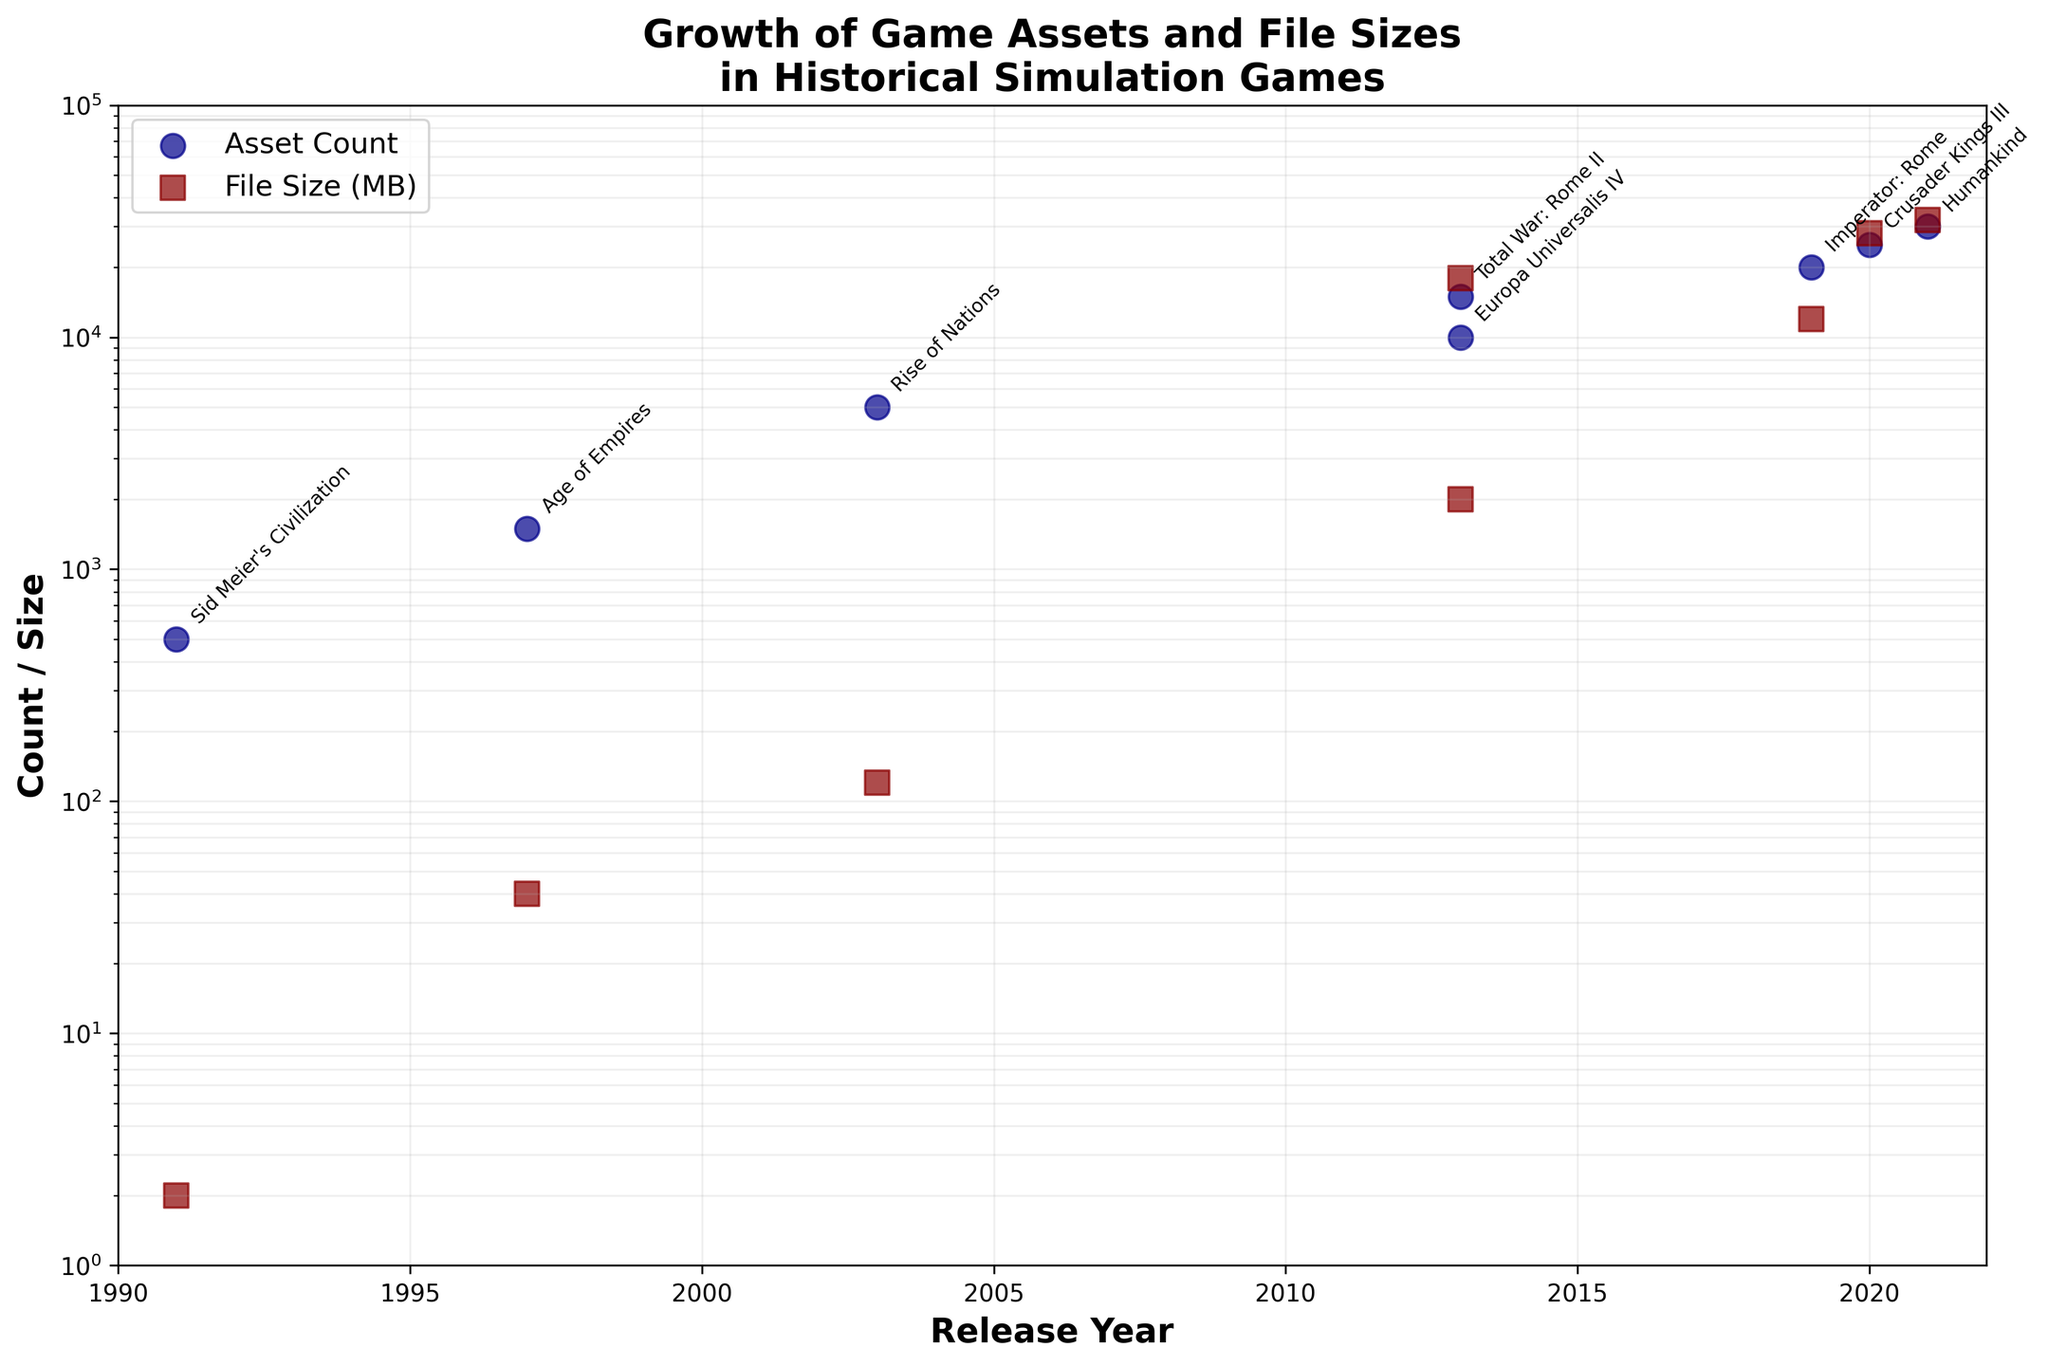What is the title of the plot? The title of the plot is written at the top and reads as "Growth of Game Assets and File Sizes in Historical Simulation Games."
Answer: Growth of Game Assets and File Sizes in Historical Simulation Games How many games are represented in the plot? By counting the distinct game titles annotated on the plot, we can determine there are 8 games represented.
Answer: 8 Which game released in 2013 has a higher file size, and what is the file size? We have two games released in 2013: "Total War: Rome II" and "Europa Universalis IV." By looking at the log scale, we can see that "Total War: Rome II" has the higher file size at approximately 18,000 MB compared to "Europa Universalis IV" with around 2,000 MB.
Answer: Total War: Rome II, 18000 MB How does the asset count of "Humankind" compare to "Crusader Kings III"? "Humankind" has an asset count of 30,000, while "Crusader Kings III" has 25,000. Comparing these counts, "Humankind" has 5,000 more assets than "Crusader Kings III."
Answer: Humankind has 5000 more assets What is the range of file sizes on the y-axis of the plot? By examining the y-axis, which is on a log scale, we see the range starts at 1 MB and extends to 100,000 MB.
Answer: 1 MB to 100,000 MB Which game has the lowest asset count, and what is the count? By checking the asset counts on the y-axis, we observe that "Sid Meier's Civilization" has the lowest asset count of 500.
Answer: Sid Meier's Civilization, 500 What is the difference in asset count between the games released in 1991 and 2021? The game released in 1991 is "Sid Meier's Civilization" with 500 assets. The game released in 2021 is "Humankind" with 30,000 assets. The difference in asset count is 30,000 - 500 = 29,500.
Answer: 29,500 What trend can be observed overall in asset counts and file sizes over time? The overall trend observed from the figure shows that both asset counts and file sizes for historical simulation games have grown exponentially over time, as evidenced by the increasing values along the log scale y-axis.
Answer: Exponential growth Which game has the largest file size and what is the size? By referring to the highest point on the file size (MB) markers, we see that "Humankind" has the largest file size with approximately 32,000 MB.
Answer: Humankind, 32000 MB What is the y-axis scale used in the plot, and why is it appropriate for this data? The y-axis scale is logarithmic (log scale). This is appropriate because the asset counts and file sizes vary by orders of magnitude, and a log scale allows for easier comparison of values that span several magnitudes.
Answer: Logarithmic 